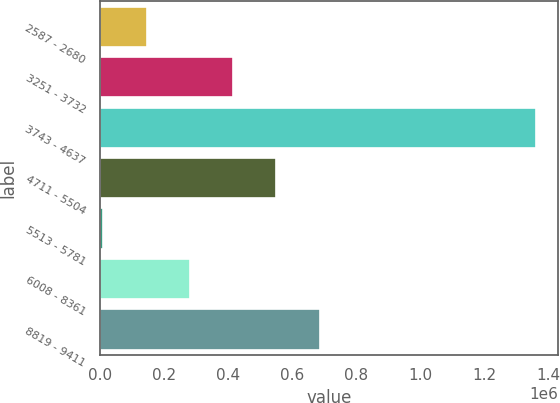Convert chart to OTSL. <chart><loc_0><loc_0><loc_500><loc_500><bar_chart><fcel>2587 - 2680<fcel>3251 - 3732<fcel>3743 - 4637<fcel>4711 - 5504<fcel>5513 - 5781<fcel>6008 - 8361<fcel>8819 - 9411<nl><fcel>145529<fcel>416086<fcel>1.36304e+06<fcel>551365<fcel>10250<fcel>280807<fcel>686644<nl></chart> 